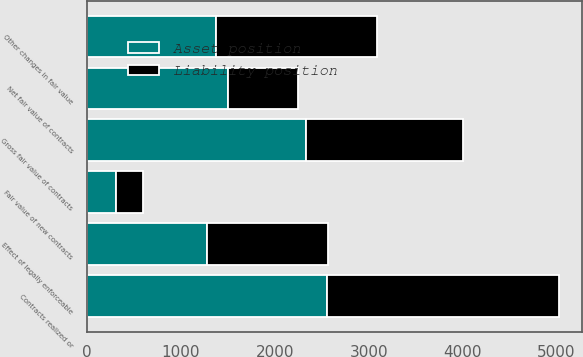Convert chart. <chart><loc_0><loc_0><loc_500><loc_500><stacked_bar_chart><ecel><fcel>Net fair value of contracts<fcel>Effect of legally enforceable<fcel>Gross fair value of contracts<fcel>Contracts realized or<fcel>Fair value of new contracts<fcel>Other changes in fair value<nl><fcel>Asset position<fcel>1497<fcel>1279<fcel>2331<fcel>2559<fcel>303<fcel>1370<nl><fcel>Liability position<fcel>751<fcel>1289<fcel>1670<fcel>2465<fcel>291<fcel>1716<nl></chart> 